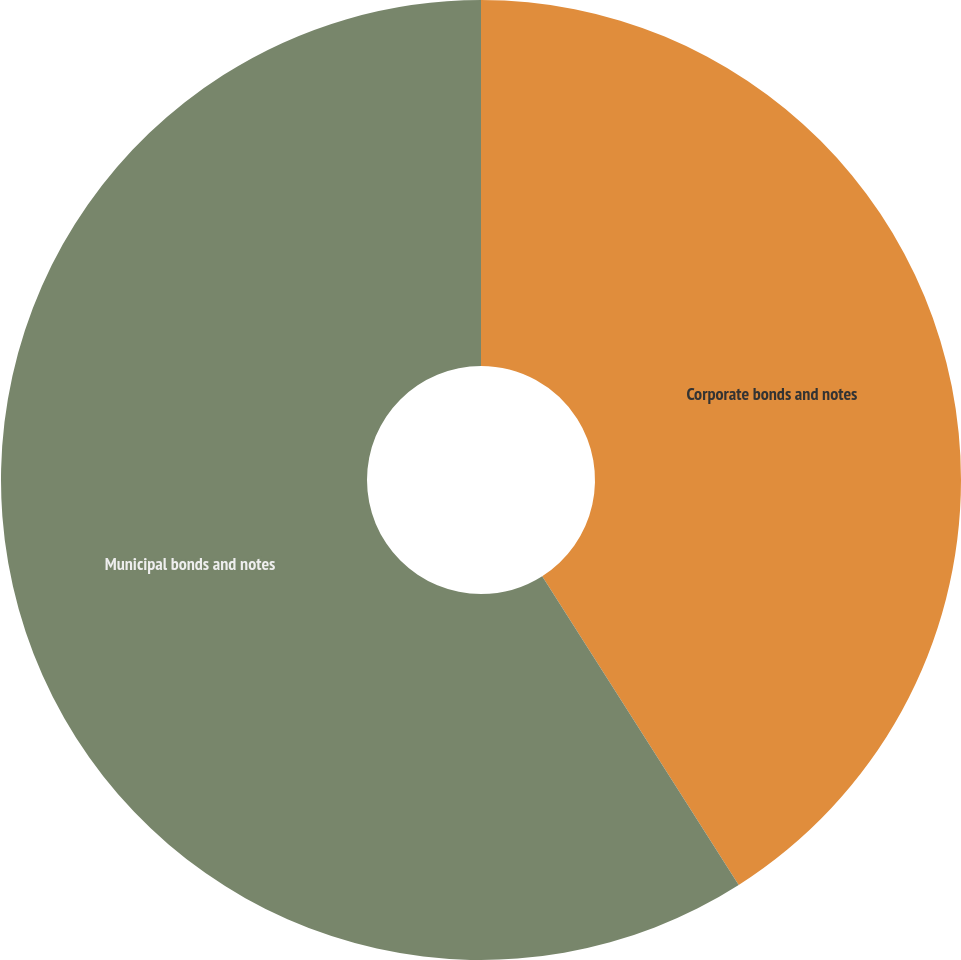<chart> <loc_0><loc_0><loc_500><loc_500><pie_chart><fcel>Corporate bonds and notes<fcel>Municipal bonds and notes<nl><fcel>40.98%<fcel>59.02%<nl></chart> 